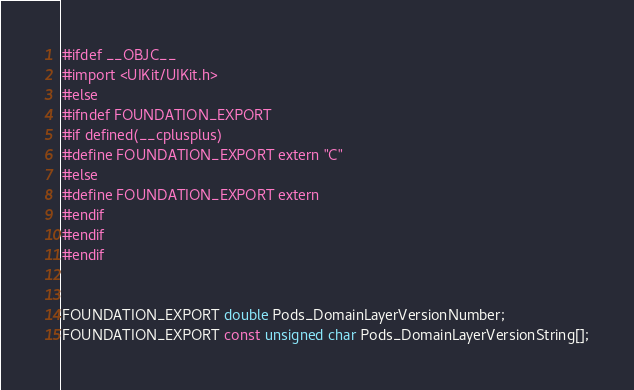<code> <loc_0><loc_0><loc_500><loc_500><_C_>#ifdef __OBJC__
#import <UIKit/UIKit.h>
#else
#ifndef FOUNDATION_EXPORT
#if defined(__cplusplus)
#define FOUNDATION_EXPORT extern "C"
#else
#define FOUNDATION_EXPORT extern
#endif
#endif
#endif


FOUNDATION_EXPORT double Pods_DomainLayerVersionNumber;
FOUNDATION_EXPORT const unsigned char Pods_DomainLayerVersionString[];

</code> 